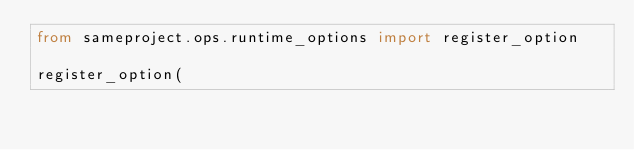<code> <loc_0><loc_0><loc_500><loc_500><_Python_>from sameproject.ops.runtime_options import register_option

register_option(</code> 